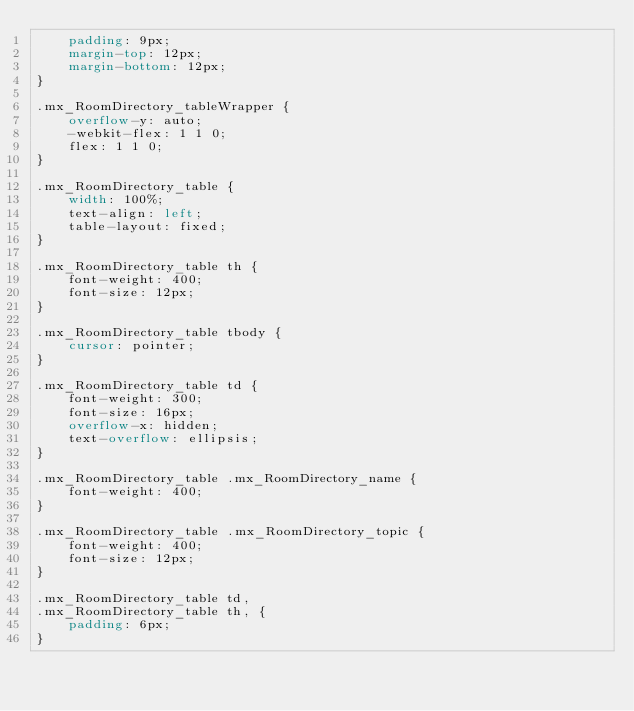Convert code to text. <code><loc_0><loc_0><loc_500><loc_500><_CSS_>    padding: 9px;
    margin-top: 12px;
    margin-bottom: 12px;
}

.mx_RoomDirectory_tableWrapper {
    overflow-y: auto;
    -webkit-flex: 1 1 0;    
    flex: 1 1 0;
}

.mx_RoomDirectory_table {
    width: 100%;
    text-align: left;
    table-layout: fixed;
}

.mx_RoomDirectory_table th {
    font-weight: 400;
    font-size: 12px;
}

.mx_RoomDirectory_table tbody {
    cursor: pointer;
}

.mx_RoomDirectory_table td {
    font-weight: 300;
    font-size: 16px;
    overflow-x: hidden;
    text-overflow: ellipsis;
}

.mx_RoomDirectory_table .mx_RoomDirectory_name {
    font-weight: 400;
}

.mx_RoomDirectory_table .mx_RoomDirectory_topic {
    font-weight: 400;
    font-size: 12px;
}

.mx_RoomDirectory_table td,
.mx_RoomDirectory_table th, {
    padding: 6px;
}</code> 